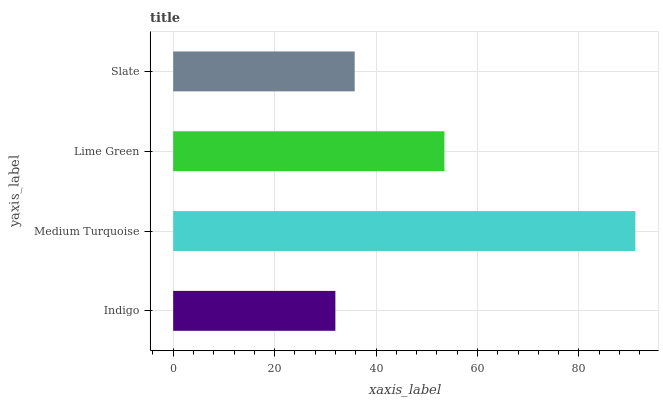Is Indigo the minimum?
Answer yes or no. Yes. Is Medium Turquoise the maximum?
Answer yes or no. Yes. Is Lime Green the minimum?
Answer yes or no. No. Is Lime Green the maximum?
Answer yes or no. No. Is Medium Turquoise greater than Lime Green?
Answer yes or no. Yes. Is Lime Green less than Medium Turquoise?
Answer yes or no. Yes. Is Lime Green greater than Medium Turquoise?
Answer yes or no. No. Is Medium Turquoise less than Lime Green?
Answer yes or no. No. Is Lime Green the high median?
Answer yes or no. Yes. Is Slate the low median?
Answer yes or no. Yes. Is Slate the high median?
Answer yes or no. No. Is Medium Turquoise the low median?
Answer yes or no. No. 